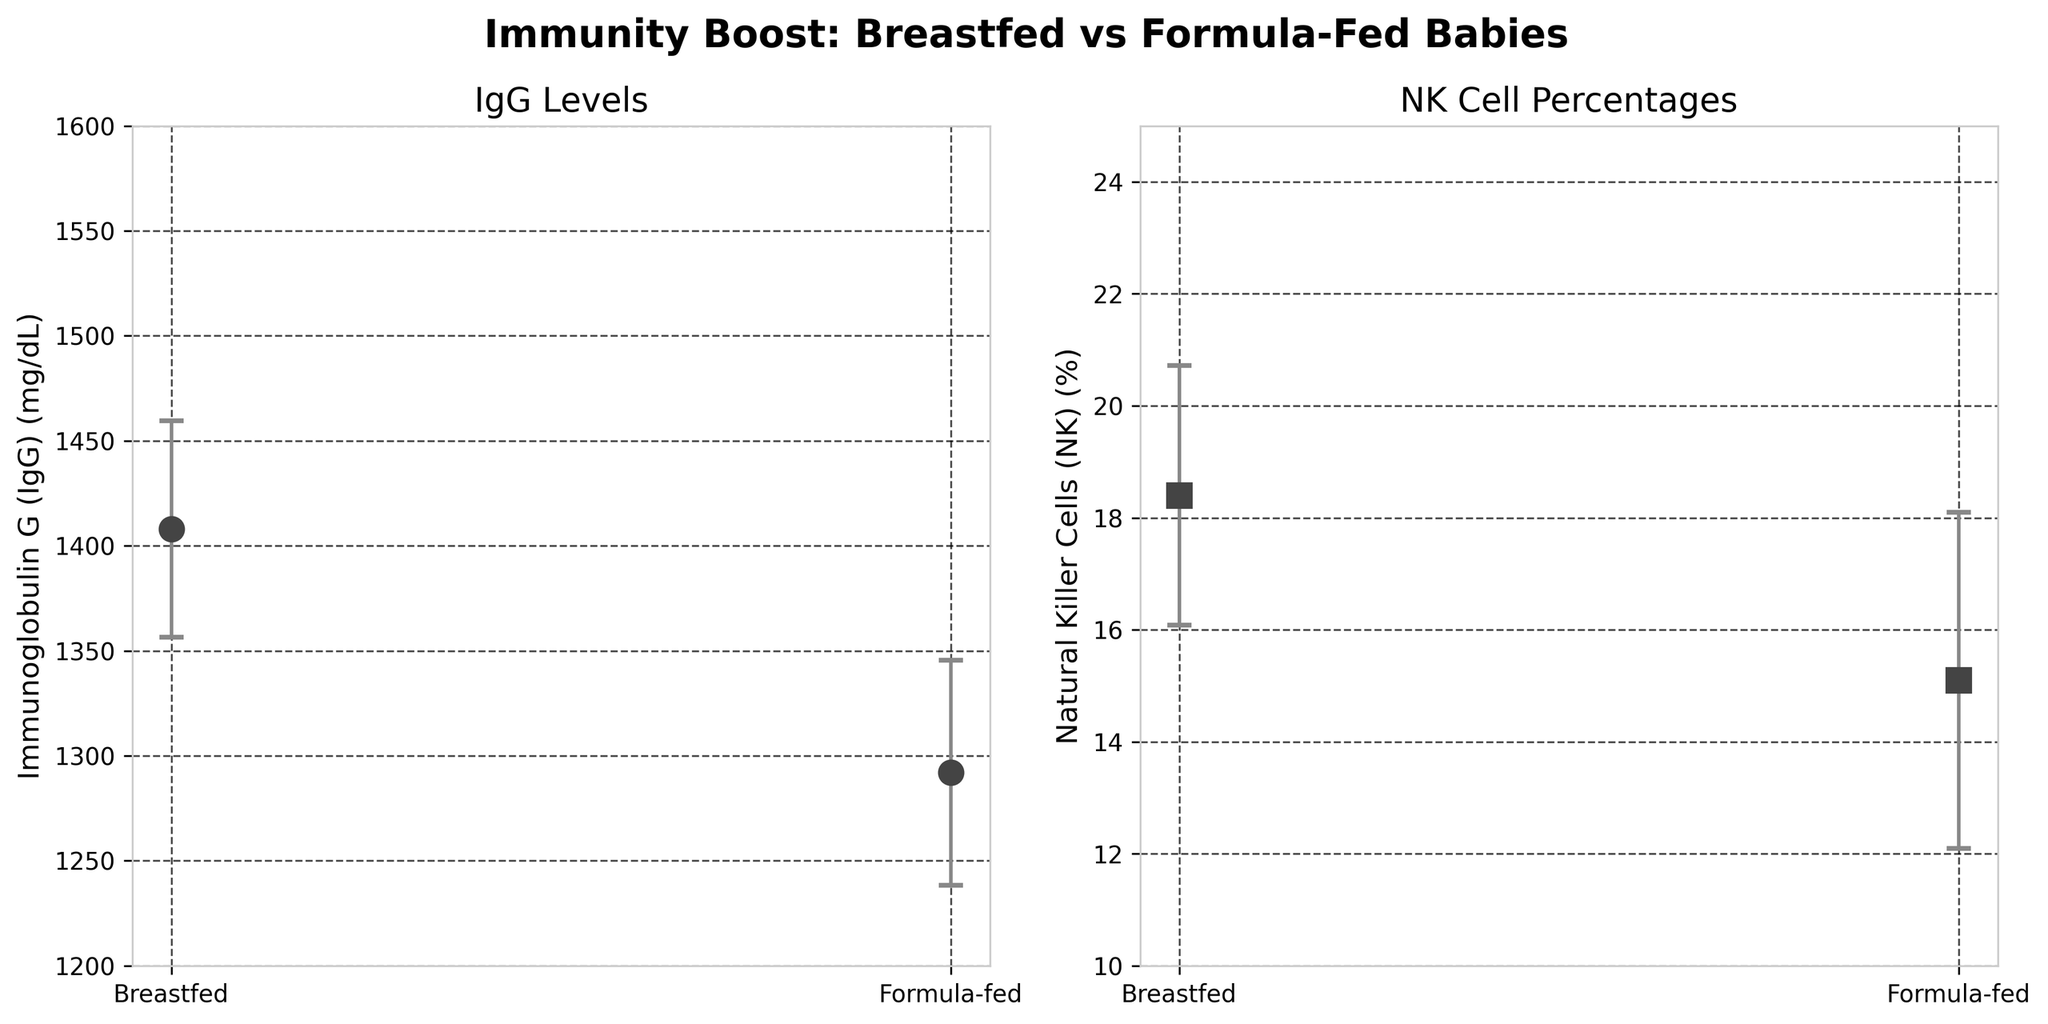What's the title of the figure? The title of the figure is usually located at the top, above the subplots. It is meant to give an overview of what the figure represents.
Answer: "Immunity Boost: Breastfed vs Formula-Fed Babies" What are the units of measurement for Immunoglobulin G (IgG) in the left subplot? The units of measurement for IgG are indicated in brackets on the y-axis. In this figure, it is represented as milligrams per deciliter (mg/dL).
Answer: mg/dL Which feeding type shows higher average NK cell percentage? Look at the right subplot, particularly the markers representing the averages. The axis will show the range, and the markers will show the average values for each feeding type.
Answer: Breastfed What is the difference in the mean IgG levels between breastfed and formula-fed babies? Look at the mean IgG levels indicated by the markers on the y-axis of the left subplot. Subtract the mean value for formula-fed from the mean value for breastfed babies.
Answer: 1408 mg/dL - 1292 mg/dL = 116 mg/dL What is the standard deviation for NK cell percentages in breastfed babies? The error bars indicate the standard deviation. Look at the length of the error bars on the right subplot for the Breastfed category.
Answer: 2.32% How much higher is the mean NK cell percentage in breastfed babies compared to formula-fed babies? Look at the right subplot. The markers indicate the mean percentages. Subtract the mean percentage for formula-fed from breastfed.
Answer: 18.4% - 15.1% = 3.3% Which side plot's y-axis ranges from 10 to 25? The range of the y-axis is indicated alongside the axis itself. Identify which subplot has this range.
Answer: Right subplot (NK Cell Percentages) What can you infer about the variability of IgG levels in breastfed versus formula-fed babies? Compare the lengths of the error bars, which represent the standard deviations, on the left subplot for both feeding types.
Answer: Breastfed babies generally show similar variability in IgG levels compared to formula-fed babies Is there an overlap in the error bars for IgG levels between breastfed and formula-fed babies? Examine the left subplot to see if the error bars for mean IgG levels overlap between the two feeding types.
Answer: No What does each marker in the plots represent? In a figure like this, markers typically represent the mean values of the data categories, which in this case are Breastfed and Formula-fed for both IgG and NK levels.
Answer: Mean values 